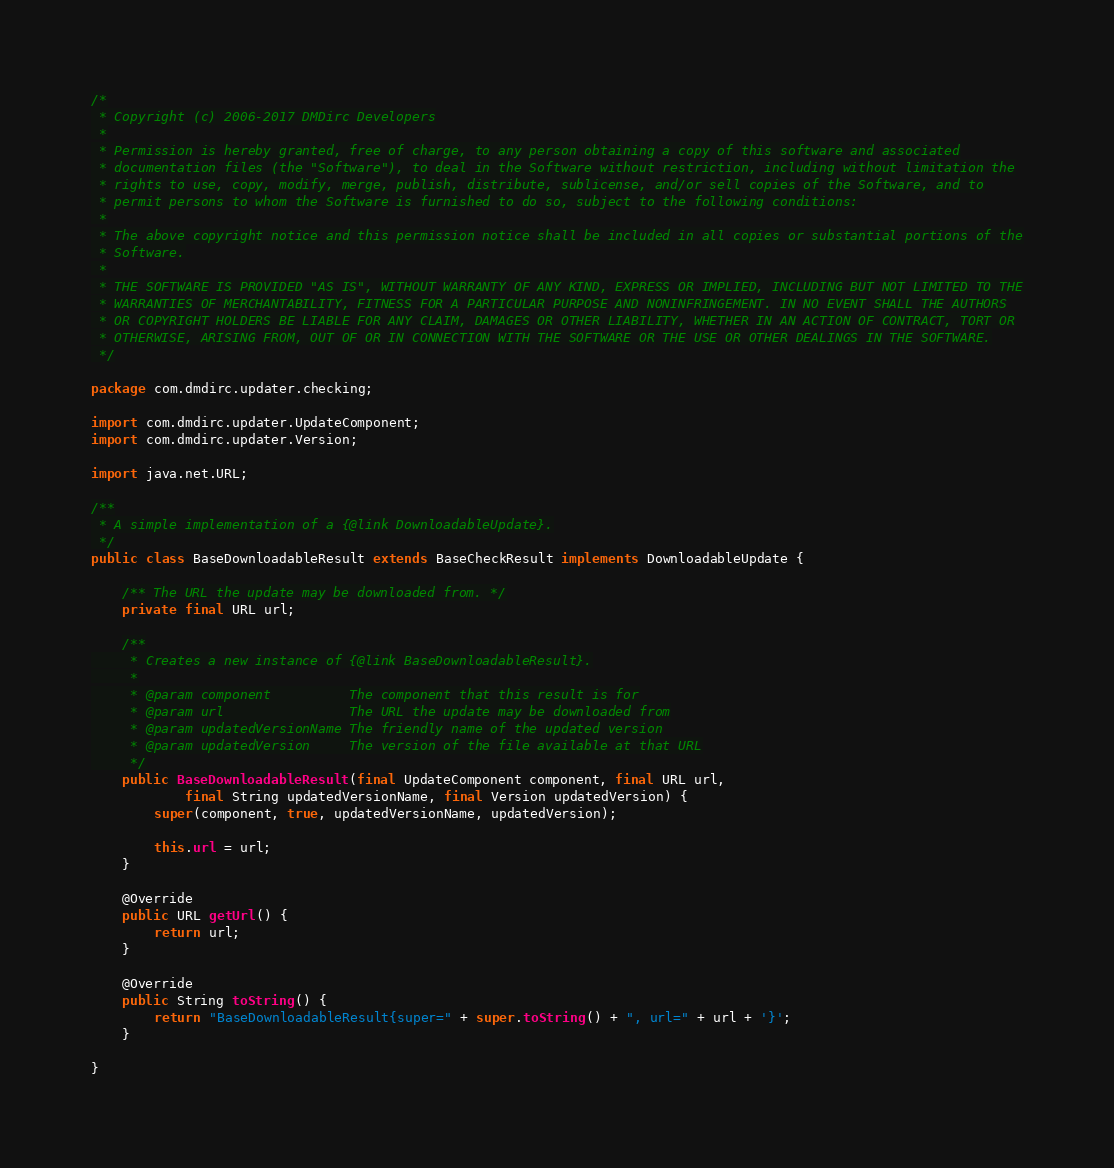<code> <loc_0><loc_0><loc_500><loc_500><_Java_>/*
 * Copyright (c) 2006-2017 DMDirc Developers
 *
 * Permission is hereby granted, free of charge, to any person obtaining a copy of this software and associated
 * documentation files (the "Software"), to deal in the Software without restriction, including without limitation the
 * rights to use, copy, modify, merge, publish, distribute, sublicense, and/or sell copies of the Software, and to
 * permit persons to whom the Software is furnished to do so, subject to the following conditions:
 *
 * The above copyright notice and this permission notice shall be included in all copies or substantial portions of the
 * Software.
 *
 * THE SOFTWARE IS PROVIDED "AS IS", WITHOUT WARRANTY OF ANY KIND, EXPRESS OR IMPLIED, INCLUDING BUT NOT LIMITED TO THE
 * WARRANTIES OF MERCHANTABILITY, FITNESS FOR A PARTICULAR PURPOSE AND NONINFRINGEMENT. IN NO EVENT SHALL THE AUTHORS
 * OR COPYRIGHT HOLDERS BE LIABLE FOR ANY CLAIM, DAMAGES OR OTHER LIABILITY, WHETHER IN AN ACTION OF CONTRACT, TORT OR
 * OTHERWISE, ARISING FROM, OUT OF OR IN CONNECTION WITH THE SOFTWARE OR THE USE OR OTHER DEALINGS IN THE SOFTWARE.
 */

package com.dmdirc.updater.checking;

import com.dmdirc.updater.UpdateComponent;
import com.dmdirc.updater.Version;

import java.net.URL;

/**
 * A simple implementation of a {@link DownloadableUpdate}.
 */
public class BaseDownloadableResult extends BaseCheckResult implements DownloadableUpdate {

    /** The URL the update may be downloaded from. */
    private final URL url;

    /**
     * Creates a new instance of {@link BaseDownloadableResult}.
     *
     * @param component          The component that this result is for
     * @param url                The URL the update may be downloaded from
     * @param updatedVersionName The friendly name of the updated version
     * @param updatedVersion     The version of the file available at that URL
     */
    public BaseDownloadableResult(final UpdateComponent component, final URL url,
            final String updatedVersionName, final Version updatedVersion) {
        super(component, true, updatedVersionName, updatedVersion);

        this.url = url;
    }

    @Override
    public URL getUrl() {
        return url;
    }

    @Override
    public String toString() {
        return "BaseDownloadableResult{super=" + super.toString() + ", url=" + url + '}';
    }

}
</code> 